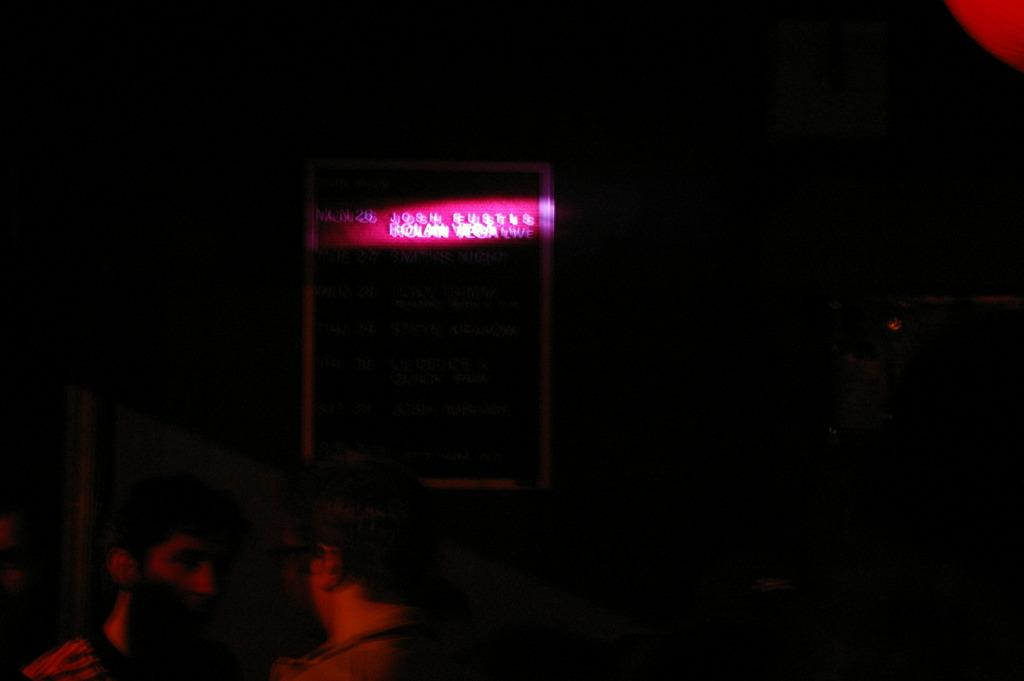How many people are in the image? There are two persons on the left bottom of the image. What can be seen in the background of the image? There is a sign board in the background of the image. What is written on the sign board? There is writing on the sign board. Is there a bridge visible in the image? No, there is no bridge present in the image. What language is used in the writing on the sign board? The language used in the writing on the sign board cannot be determined from the image alone. 